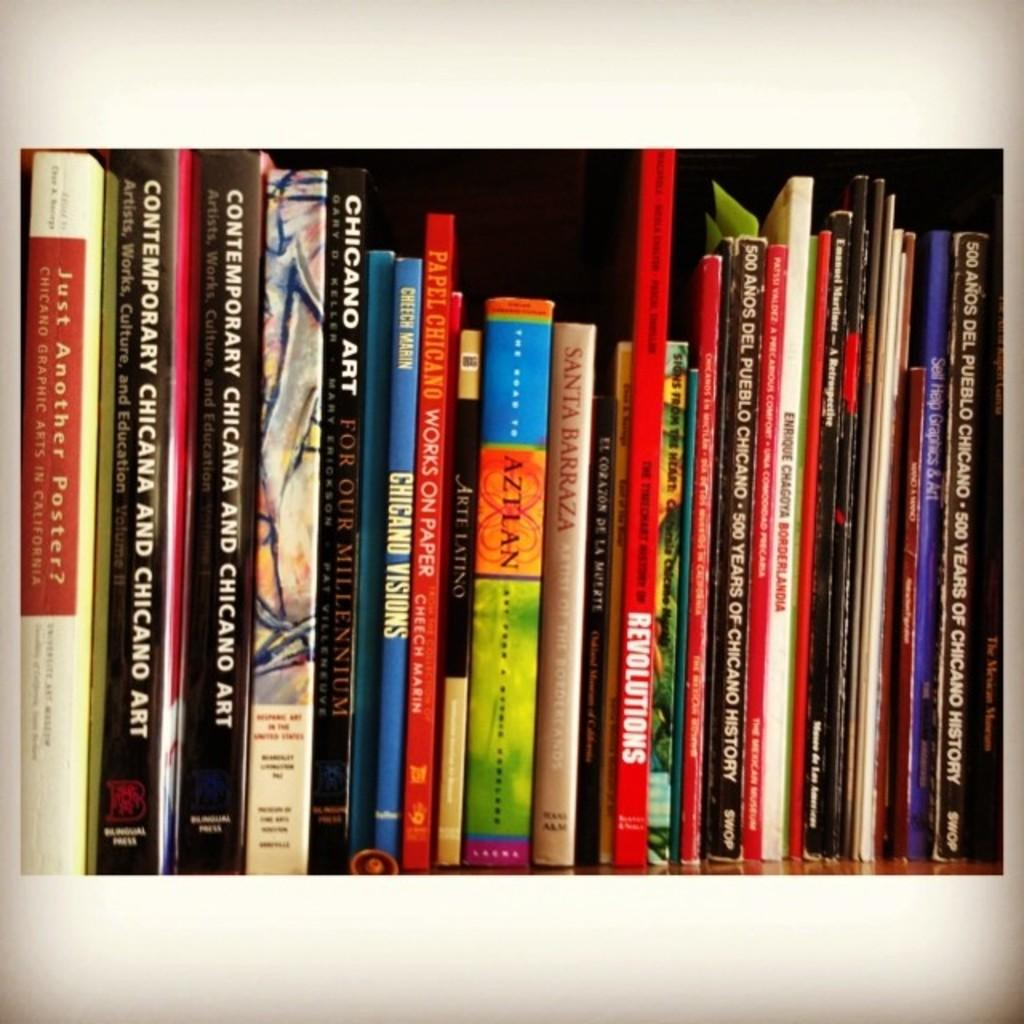Provide a one-sentence caption for the provided image. A row of colorful books many of them having Chicago and Art in their titles. 